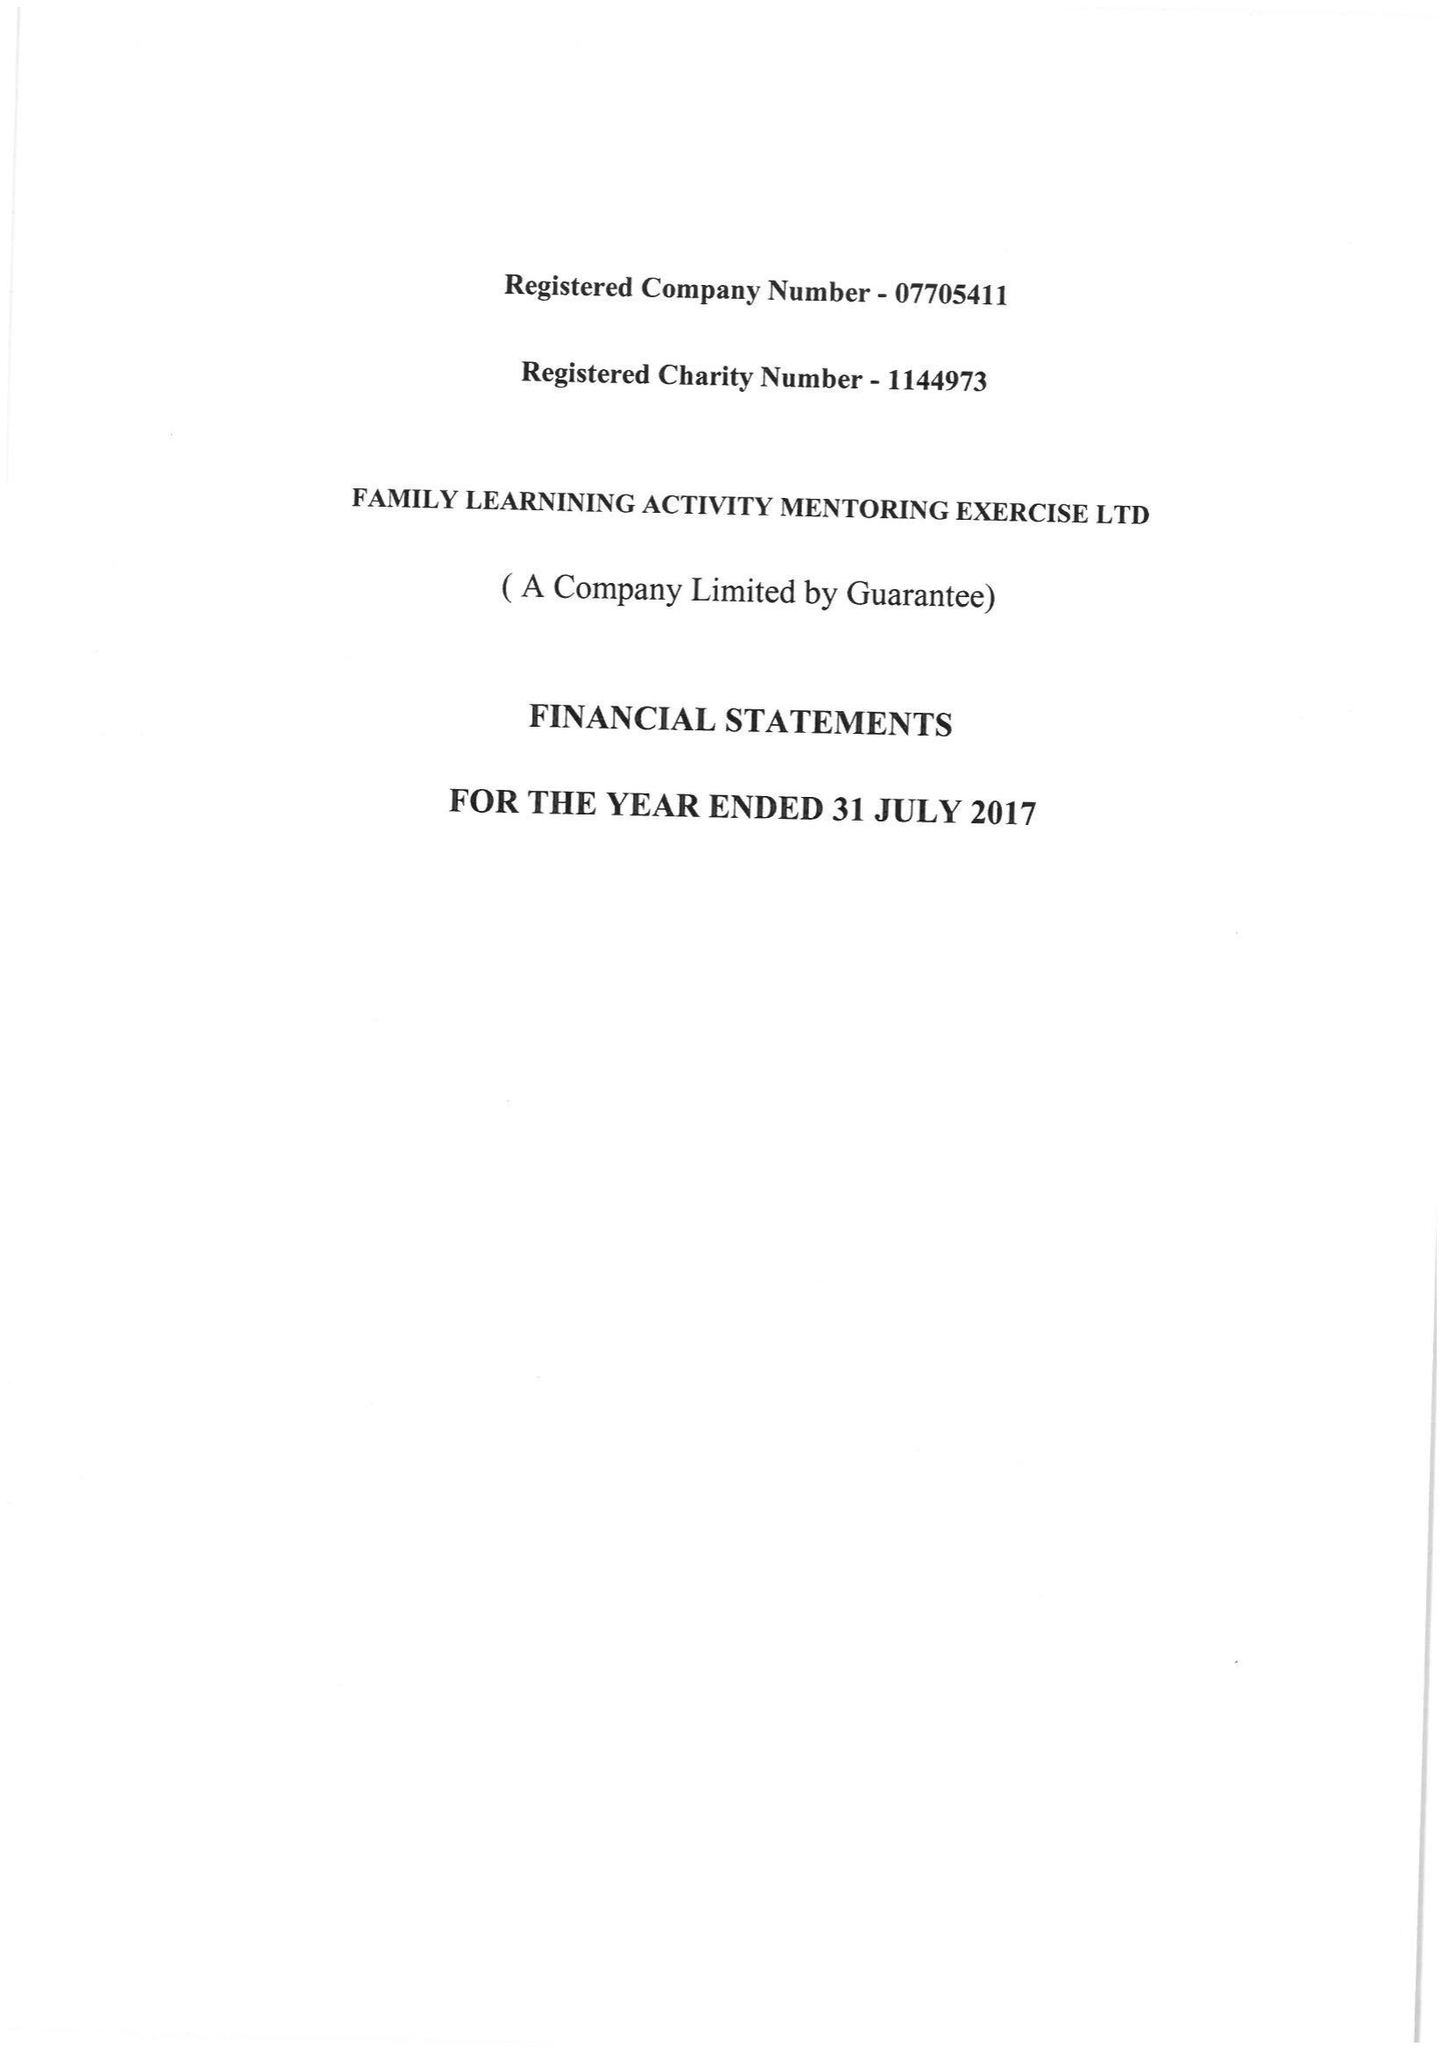What is the value for the address__post_town?
Answer the question using a single word or phrase. LONDON 